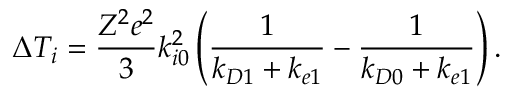Convert formula to latex. <formula><loc_0><loc_0><loc_500><loc_500>\Delta T _ { i } = \frac { Z ^ { 2 } e ^ { 2 } } { 3 } k _ { i 0 } ^ { 2 } \left ( \frac { 1 } { k _ { D 1 } + k _ { e 1 } } - \frac { 1 } { k _ { D 0 } + k _ { e 1 } } \right ) .</formula> 